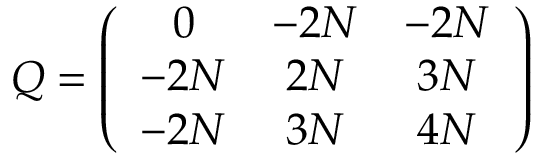<formula> <loc_0><loc_0><loc_500><loc_500>Q = \left ( \begin{array} { c c c } { 0 } & { - 2 N } & { - 2 N } \\ { - 2 N } & { 2 N } & { 3 N } \\ { - 2 N } & { 3 N } & { 4 N } \end{array} \right )</formula> 